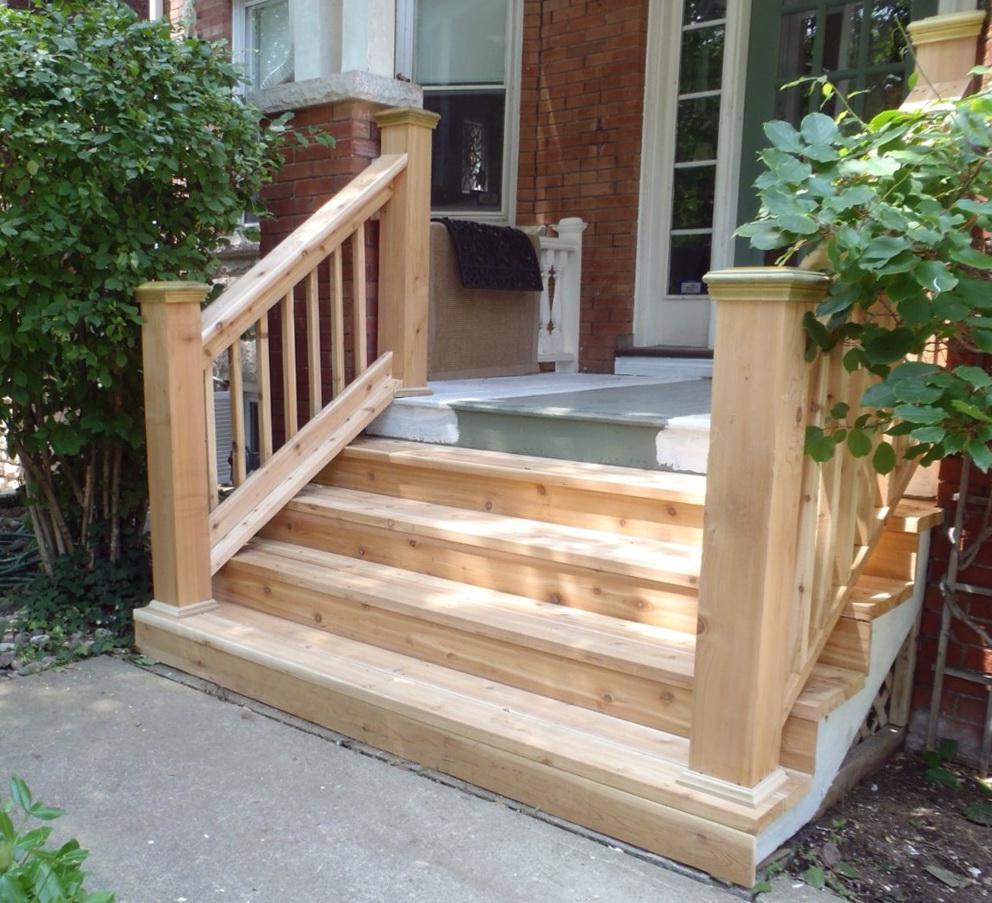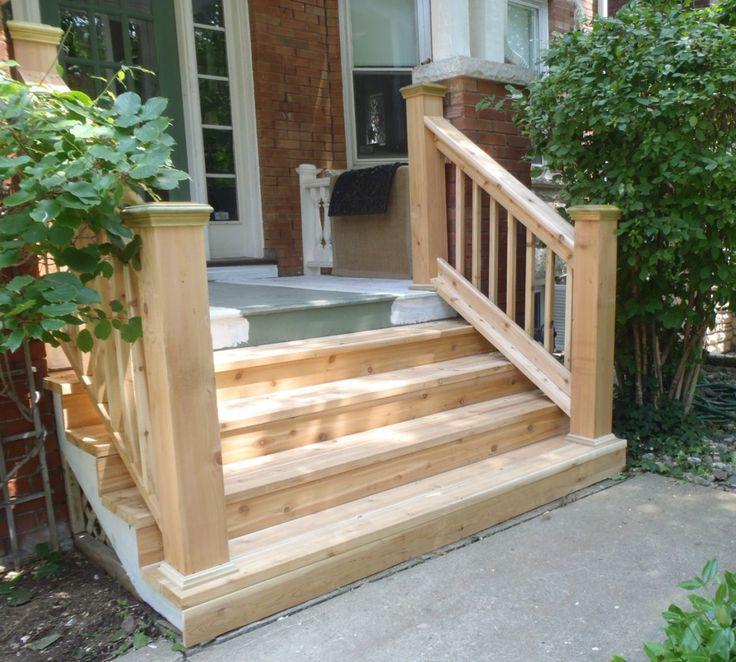The first image is the image on the left, the second image is the image on the right. Assess this claim about the two images: "The left and right image contains the same number of staircases.". Correct or not? Answer yes or no. Yes. 